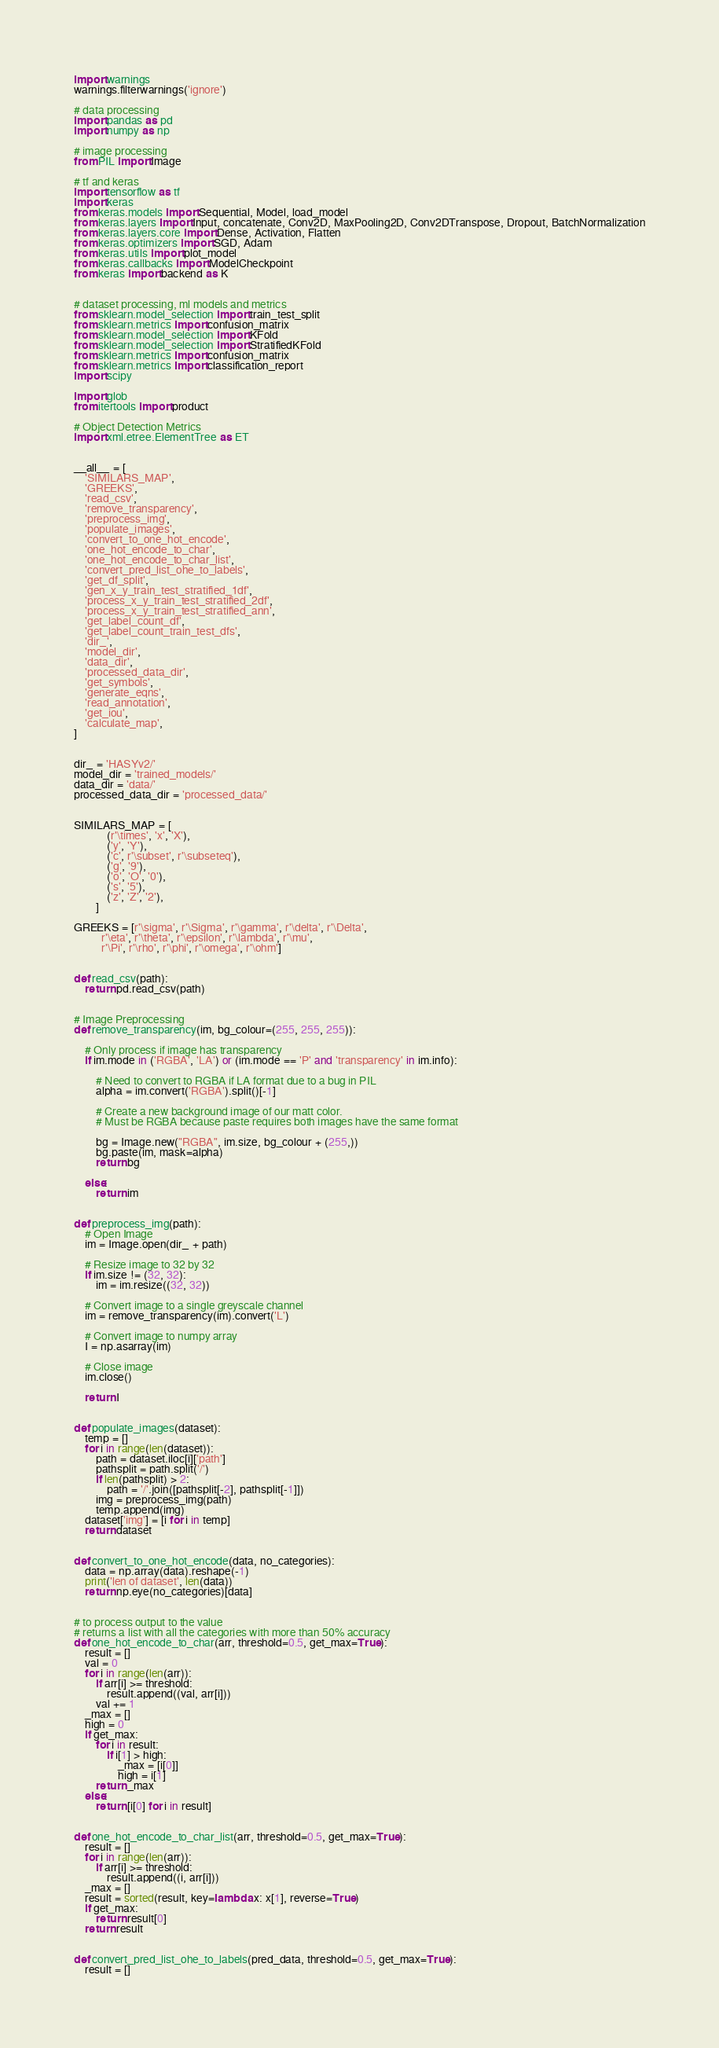Convert code to text. <code><loc_0><loc_0><loc_500><loc_500><_Python_>import warnings
warnings.filterwarnings('ignore')

# data processing
import pandas as pd
import numpy as np

# image processing
from PIL import Image

# tf and keras
import tensorflow as tf
import keras
from keras.models import Sequential, Model, load_model
from keras.layers import Input, concatenate, Conv2D, MaxPooling2D, Conv2DTranspose, Dropout, BatchNormalization
from keras.layers.core import Dense, Activation, Flatten
from keras.optimizers import SGD, Adam
from keras.utils import plot_model
from keras.callbacks import ModelCheckpoint
from keras import backend as K


# dataset processing, ml models and metrics
from sklearn.model_selection import train_test_split
from sklearn.metrics import confusion_matrix
from sklearn.model_selection import KFold
from sklearn.model_selection import StratifiedKFold
from sklearn.metrics import confusion_matrix
from sklearn.metrics import classification_report
import scipy

import glob
from itertools import product

# Object Detection Metrics
import xml.etree.ElementTree as ET


__all__ = [
    'SIMILARS_MAP',
    'GREEKS',
    'read_csv',
    'remove_transparency',
    'preprocess_img',
    'populate_images',
    'convert_to_one_hot_encode',
    'one_hot_encode_to_char',
    'one_hot_encode_to_char_list',
    'convert_pred_list_ohe_to_labels',
    'get_df_split',
    'gen_x_y_train_test_stratified_1df',
    'process_x_y_train_test_stratified_2df',
    'process_x_y_train_test_stratified_ann',
    'get_label_count_df',
    'get_label_count_train_test_dfs',
    'dir_',
    'model_dir',
    'data_dir',
    'processed_data_dir',
    'get_symbols',
    'generate_eqns',
    'read_annotation',
    'get_iou',
    'calculate_map',
]


dir_ = 'HASYv2/'
model_dir = 'trained_models/'
data_dir = 'data/'
processed_data_dir = 'processed_data/'


SIMILARS_MAP = [
            (r'\times', 'x', 'X'),
            ('y', 'Y'),
            ('c', r'\subset', r'\subseteq'),
            ('g', '9'),
            ('o', 'O', '0'),
            ('s', '5'),
            ('z', 'Z', '2'),
        ]

GREEKS = [r'\sigma', r'\Sigma', r'\gamma', r'\delta', r'\Delta',
          r'\eta', r'\theta', r'\epsilon', r'\lambda', r'\mu',
          r'\Pi', r'\rho', r'\phi', r'\omega', r'\ohm']


def read_csv(path):
    return pd.read_csv(path)


# Image Preprocessing
def remove_transparency(im, bg_colour=(255, 255, 255)):

    # Only process if image has transparency 
    if im.mode in ('RGBA', 'LA') or (im.mode == 'P' and 'transparency' in im.info):

        # Need to convert to RGBA if LA format due to a bug in PIL 
        alpha = im.convert('RGBA').split()[-1]

        # Create a new background image of our matt color.
        # Must be RGBA because paste requires both images have the same format

        bg = Image.new("RGBA", im.size, bg_colour + (255,))
        bg.paste(im, mask=alpha)
        return bg

    else:
        return im


def preprocess_img(path):
    # Open Image
    im = Image.open(dir_ + path)
    
    # Resize image to 32 by 32
    if im.size != (32, 32):
        im = im.resize((32, 32))
        
    # Convert image to a single greyscale channel
    im = remove_transparency(im).convert('L')
    
    # Convert image to numpy array
    I = np.asarray(im)
    
    # Close image
    im.close()
    
    return I


def populate_images(dataset):
    temp = []
    for i in range(len(dataset)):
        path = dataset.iloc[i]['path']
        pathsplit = path.split('/')
        if len(pathsplit) > 2:
            path = '/'.join([pathsplit[-2], pathsplit[-1]])
        img = preprocess_img(path)
        temp.append(img)
    dataset['img'] = [i for i in temp]
    return dataset


def convert_to_one_hot_encode(data, no_categories):
    data = np.array(data).reshape(-1)
    print('len of dataset', len(data))
    return np.eye(no_categories)[data]


# to process output to the value
# returns a list with all the categories with more than 50% accuracy
def one_hot_encode_to_char(arr, threshold=0.5, get_max=True):
    result = []
    val = 0
    for i in range(len(arr)):
        if arr[i] >= threshold:
            result.append((val, arr[i]))
        val += 1
    _max = []
    high = 0
    if get_max:
        for i in result:
            if i[1] > high:
                _max = [i[0]]
                high = i[1]
        return _max
    else:
        return [i[0] for i in result]


def one_hot_encode_to_char_list(arr, threshold=0.5, get_max=True):
    result = []
    for i in range(len(arr)):
        if arr[i] >= threshold:
            result.append((i, arr[i]))
    _max = []
    result = sorted(result, key=lambda x: x[1], reverse=True)
    if get_max:
        return result[0]
    return result


def convert_pred_list_ohe_to_labels(pred_data, threshold=0.5, get_max=True):
    result = []</code> 